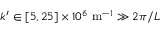Convert formula to latex. <formula><loc_0><loc_0><loc_500><loc_500>k ^ { \prime } \in [ 5 , 2 5 ] \times 1 0 ^ { 6 } \ m ^ { - 1 } \gg 2 \pi / L</formula> 